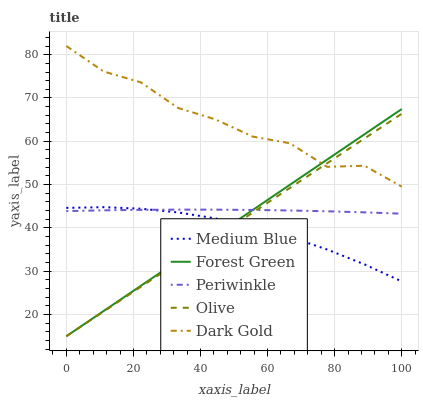Does Medium Blue have the minimum area under the curve?
Answer yes or no. Yes. Does Dark Gold have the maximum area under the curve?
Answer yes or no. Yes. Does Periwinkle have the minimum area under the curve?
Answer yes or no. No. Does Periwinkle have the maximum area under the curve?
Answer yes or no. No. Is Olive the smoothest?
Answer yes or no. Yes. Is Dark Gold the roughest?
Answer yes or no. Yes. Is Periwinkle the smoothest?
Answer yes or no. No. Is Periwinkle the roughest?
Answer yes or no. No. Does Olive have the lowest value?
Answer yes or no. Yes. Does Periwinkle have the lowest value?
Answer yes or no. No. Does Dark Gold have the highest value?
Answer yes or no. Yes. Does Forest Green have the highest value?
Answer yes or no. No. Is Medium Blue less than Dark Gold?
Answer yes or no. Yes. Is Dark Gold greater than Periwinkle?
Answer yes or no. Yes. Does Dark Gold intersect Olive?
Answer yes or no. Yes. Is Dark Gold less than Olive?
Answer yes or no. No. Is Dark Gold greater than Olive?
Answer yes or no. No. Does Medium Blue intersect Dark Gold?
Answer yes or no. No. 